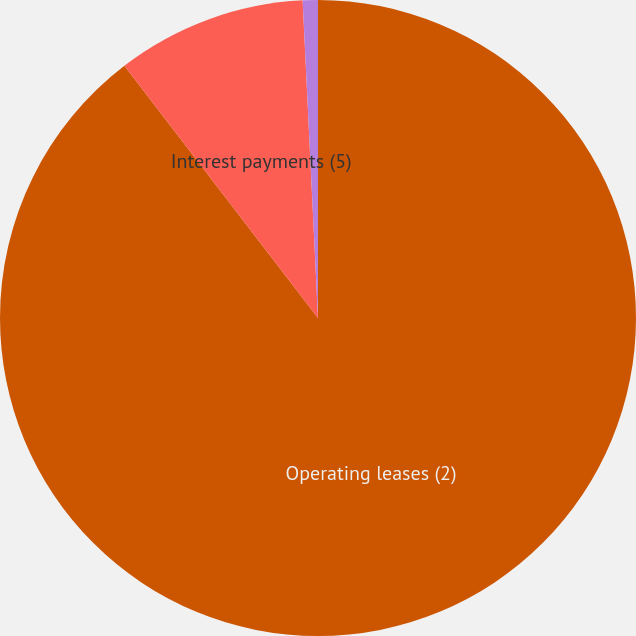<chart> <loc_0><loc_0><loc_500><loc_500><pie_chart><fcel>Operating leases (2)<fcel>Interest payments (5)<fcel>Long-term debt (6)<nl><fcel>89.58%<fcel>9.65%<fcel>0.77%<nl></chart> 